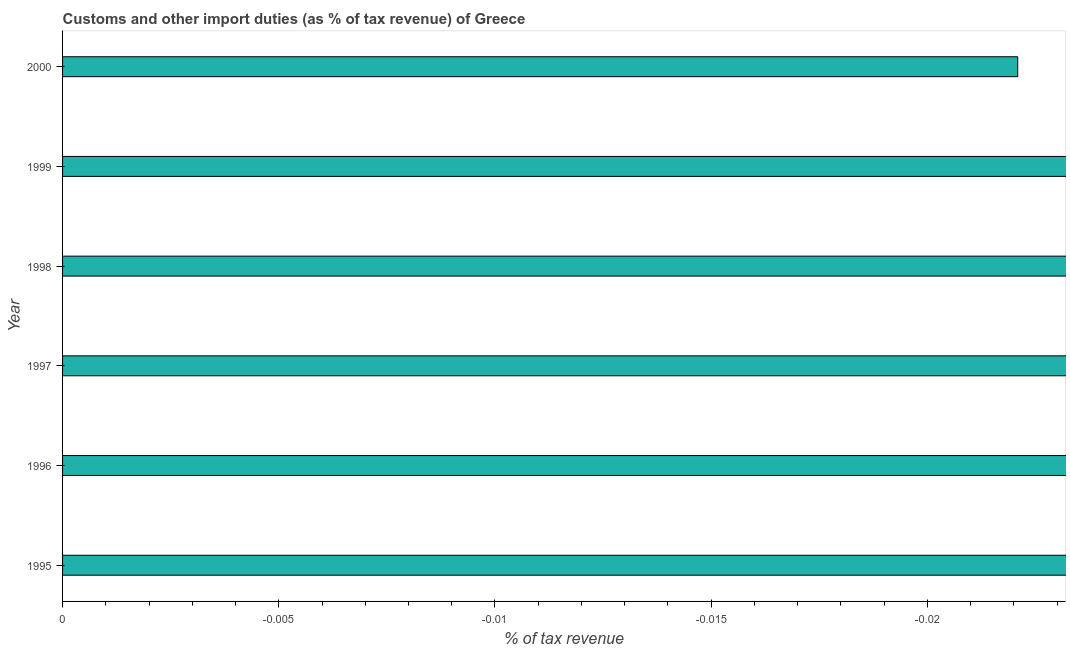Does the graph contain any zero values?
Provide a succinct answer. Yes. What is the title of the graph?
Make the answer very short. Customs and other import duties (as % of tax revenue) of Greece. What is the label or title of the X-axis?
Give a very brief answer. % of tax revenue. Across all years, what is the minimum customs and other import duties?
Offer a terse response. 0. What is the median customs and other import duties?
Ensure brevity in your answer.  0. In how many years, is the customs and other import duties greater than the average customs and other import duties taken over all years?
Your response must be concise. 0. Are all the bars in the graph horizontal?
Make the answer very short. Yes. What is the difference between two consecutive major ticks on the X-axis?
Provide a succinct answer. 0.01. What is the % of tax revenue in 1998?
Keep it short and to the point. 0. 